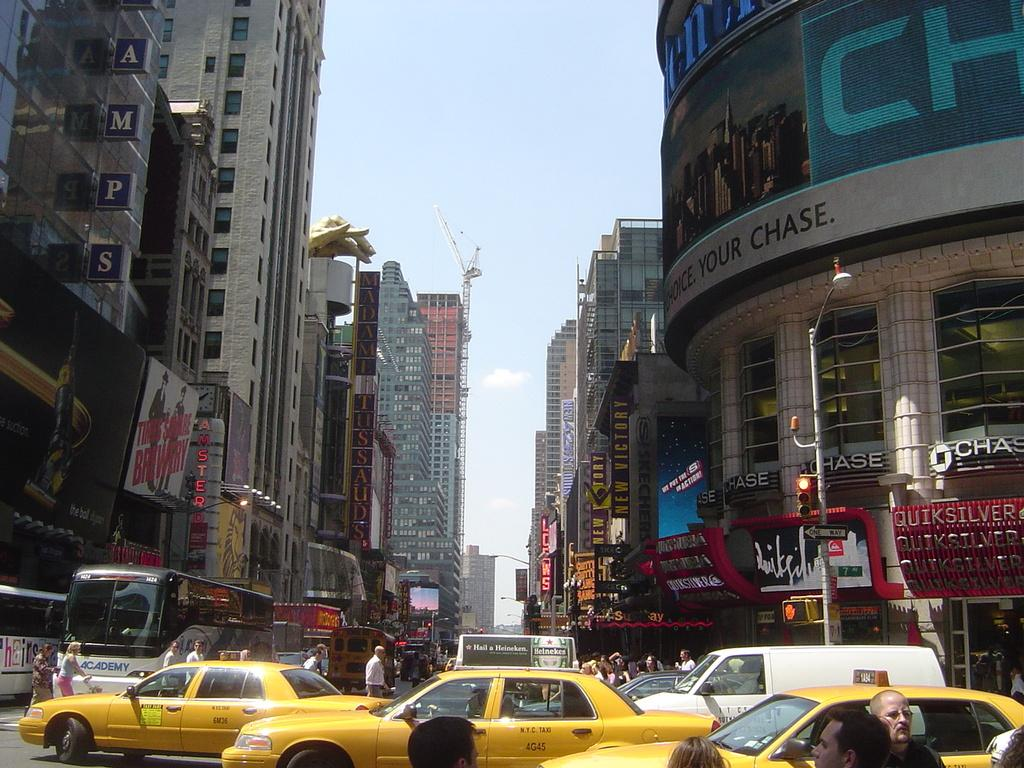<image>
Offer a succinct explanation of the picture presented. A street in a major city, by a Chase bank, is extremely busy with both traffic and pedestrians. 